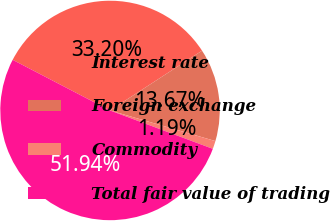<chart> <loc_0><loc_0><loc_500><loc_500><pie_chart><fcel>Interest rate<fcel>Foreign exchange<fcel>Commodity<fcel>Total fair value of trading<nl><fcel>33.2%<fcel>13.67%<fcel>1.19%<fcel>51.95%<nl></chart> 